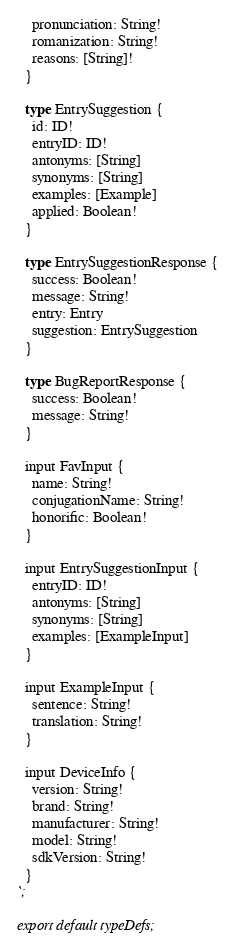<code> <loc_0><loc_0><loc_500><loc_500><_TypeScript_>    pronunciation: String!
    romanization: String!
    reasons: [String]!
  }

  type EntrySuggestion {
    id: ID!
    entryID: ID!
    antonyms: [String]
    synonyms: [String]
    examples: [Example]
    applied: Boolean!
  }

  type EntrySuggestionResponse {
    success: Boolean!
    message: String!
    entry: Entry
    suggestion: EntrySuggestion
  }

  type BugReportResponse {
    success: Boolean!
    message: String!
  }

  input FavInput {
    name: String!
    conjugationName: String!
    honorific: Boolean!
  }

  input EntrySuggestionInput {
    entryID: ID!
    antonyms: [String]
    synonyms: [String]
    examples: [ExampleInput]
  }

  input ExampleInput {
    sentence: String!
    translation: String!
  }

  input DeviceInfo {
    version: String!
    brand: String!
    manufacturer: String!
    model: String!
    sdkVersion: String!
  }
`;

export default typeDefs;
</code> 